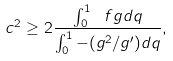<formula> <loc_0><loc_0><loc_500><loc_500>c ^ { 2 } \geq 2 \frac { \int _ { 0 } ^ { 1 } \ f g d q } { \int _ { 0 } ^ { 1 } - ( g ^ { 2 } / g ^ { \prime } ) d q } ,</formula> 